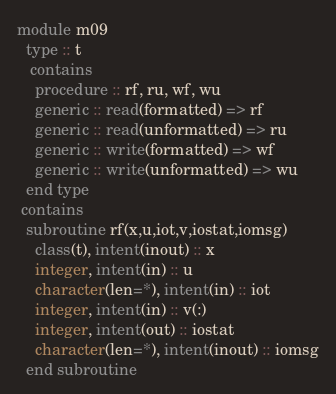Convert code to text. <code><loc_0><loc_0><loc_500><loc_500><_FORTRAN_>module m09
  type :: t
   contains
    procedure :: rf, ru, wf, wu
    generic :: read(formatted) => rf
    generic :: read(unformatted) => ru
    generic :: write(formatted) => wf
    generic :: write(unformatted) => wu
  end type
 contains
  subroutine rf(x,u,iot,v,iostat,iomsg)
    class(t), intent(inout) :: x
    integer, intent(in) :: u
    character(len=*), intent(in) :: iot
    integer, intent(in) :: v(:)
    integer, intent(out) :: iostat
    character(len=*), intent(inout) :: iomsg
  end subroutine</code> 